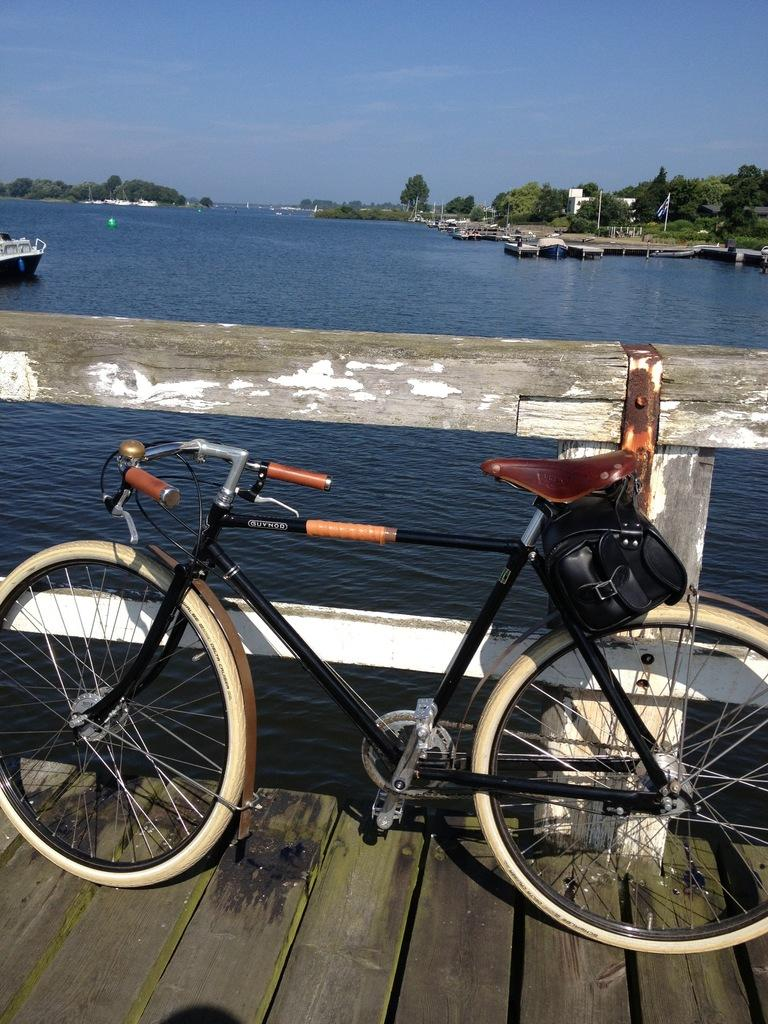What is the main subject of the image? There is a bicycle on a bridge in the image. What can be seen in the background of the image? There are boats, water, trees, and a house visible in the background of the image. What type of orange is hanging from the trees in the image? There are no oranges present in the image; the trees are not specified as fruit-bearing trees. Can you hear a bell ringing in the image? There is no mention of a bell or any sound in the image, so it cannot be determined if a bell is ringing. 